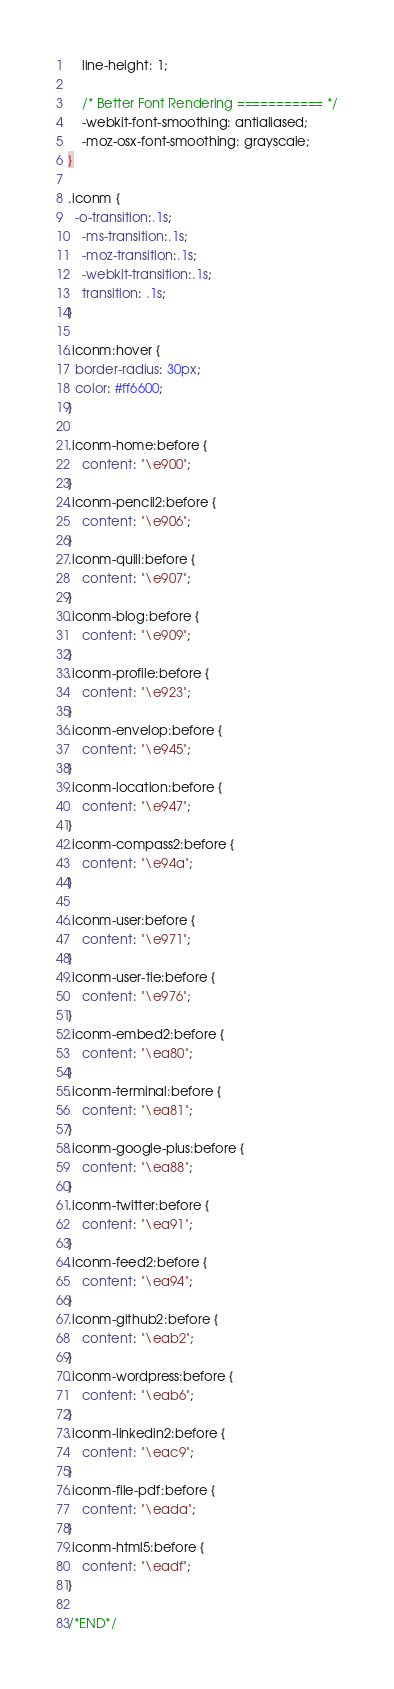<code> <loc_0><loc_0><loc_500><loc_500><_CSS_>    line-height: 1;

    /* Better Font Rendering =========== */
    -webkit-font-smoothing: antialiased;
    -moz-osx-font-smoothing: grayscale;
}

.iconm {
  -o-transition:.1s;
    -ms-transition:.1s;
    -moz-transition:.1s;
    -webkit-transition:.1s;
    transition: .1s;
}

.iconm:hover {
  border-radius: 30px;
  color: #ff6600;
}

.iconm-home:before {
    content: "\e900";
}
.iconm-pencil2:before {
    content: "\e906";
}
.iconm-quill:before {
    content: "\e907";
}
.iconm-blog:before {
    content: "\e909";
}
.iconm-profile:before {
    content: "\e923";
}
.iconm-envelop:before {
    content: "\e945";
}
.iconm-location:before {
    content: "\e947";
}
.iconm-compass2:before {
    content: "\e94a";
}

.iconm-user:before {
    content: "\e971";
}
.iconm-user-tie:before {
    content: "\e976";
}
.iconm-embed2:before {
    content: "\ea80";
}
.iconm-terminal:before {
    content: "\ea81";
}
.iconm-google-plus:before {
    content: "\ea88";
}
.iconm-twitter:before {
    content: "\ea91";
}
.iconm-feed2:before {
    content: "\ea94";
}
.iconm-github2:before {
    content: "\eab2";
}
.iconm-wordpress:before {
    content: "\eab6";
}
.iconm-linkedin2:before {
    content: "\eac9";
}
.iconm-file-pdf:before {
    content: "\eada";
}
.iconm-html5:before {
    content: "\eadf";
}

/*END*/
</code> 